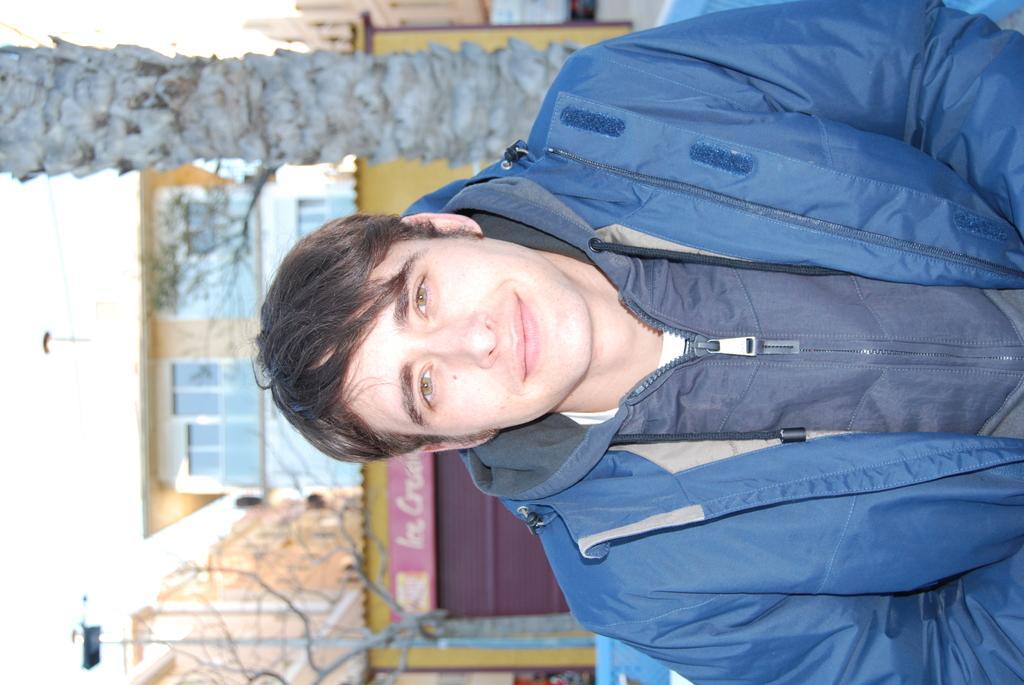Could you give a brief overview of what you see in this image? In this image we can see a person wearing a dress. In the background, we can see a group of trees, light poles, building with windows, sign board with some text and the sky. 